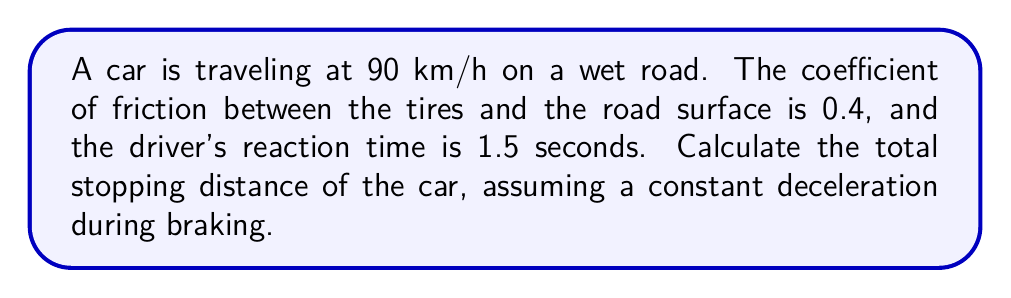Can you answer this question? To calculate the total stopping distance, we need to consider both the distance traveled during the driver's reaction time and the braking distance. Let's break this down step-by-step:

1. Convert the initial speed from km/h to m/s:
   $$ v_0 = 90 \frac{km}{h} \times \frac{1000 m}{1 km} \times \frac{1 h}{3600 s} = 25 \frac{m}{s} $$

2. Calculate the distance traveled during the reaction time:
   $$ d_{reaction} = v_0 \times t_{reaction} = 25 \frac{m}{s} \times 1.5 s = 37.5 m $$

3. For the braking distance, we'll use the equation of motion:
   $$ v^2 = v_0^2 + 2a\Delta x $$
   where $v$ is the final velocity (0 m/s), $v_0$ is the initial velocity, $a$ is the deceleration, and $\Delta x$ is the braking distance.

4. Calculate the deceleration using the coefficient of friction:
   $$ a = \mu g $$
   where $\mu$ is the coefficient of friction and $g$ is the acceleration due to gravity (9.8 m/s²).
   $$ a = 0.4 \times 9.8 \frac{m}{s^2} = 3.92 \frac{m}{s^2} $$

5. Rearrange the equation of motion to solve for the braking distance:
   $$ \Delta x = -\frac{v_0^2}{2a} = -\frac{(25 \frac{m}{s})^2}{2 \times 3.92 \frac{m}{s^2}} = 79.59 m $$

6. Calculate the total stopping distance:
   $$ d_{total} = d_{reaction} + d_{braking} = 37.5 m + 79.59 m = 117.09 m $$
Answer: 117.09 m 